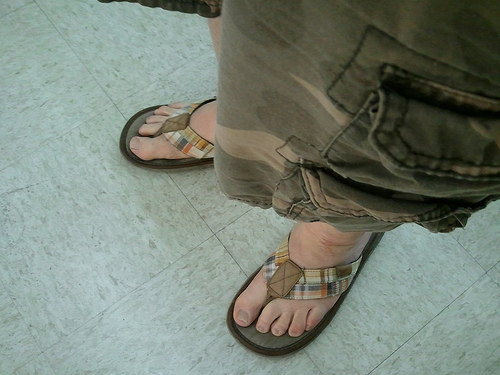<image>
Can you confirm if the shorts is on the flip flop? No. The shorts is not positioned on the flip flop. They may be near each other, but the shorts is not supported by or resting on top of the flip flop. 